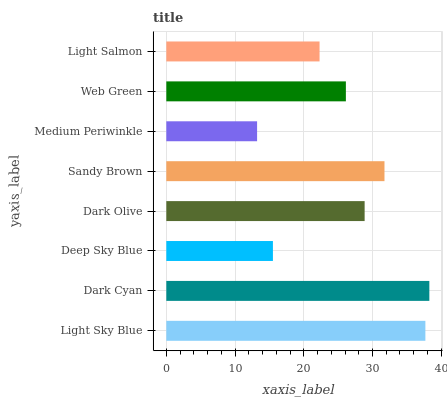Is Medium Periwinkle the minimum?
Answer yes or no. Yes. Is Dark Cyan the maximum?
Answer yes or no. Yes. Is Deep Sky Blue the minimum?
Answer yes or no. No. Is Deep Sky Blue the maximum?
Answer yes or no. No. Is Dark Cyan greater than Deep Sky Blue?
Answer yes or no. Yes. Is Deep Sky Blue less than Dark Cyan?
Answer yes or no. Yes. Is Deep Sky Blue greater than Dark Cyan?
Answer yes or no. No. Is Dark Cyan less than Deep Sky Blue?
Answer yes or no. No. Is Dark Olive the high median?
Answer yes or no. Yes. Is Web Green the low median?
Answer yes or no. Yes. Is Web Green the high median?
Answer yes or no. No. Is Dark Olive the low median?
Answer yes or no. No. 